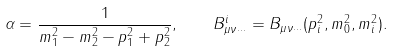Convert formula to latex. <formula><loc_0><loc_0><loc_500><loc_500>\alpha = \frac { 1 } { m _ { 1 } ^ { 2 } - m _ { 2 } ^ { 2 } - p _ { 1 } ^ { 2 } + p _ { 2 } ^ { 2 } } , \quad B ^ { i } _ { \mu \nu \cdots } = B _ { \mu \nu \cdots } ( p _ { i } ^ { 2 } , m _ { 0 } ^ { 2 } , m _ { i } ^ { 2 } ) .</formula> 